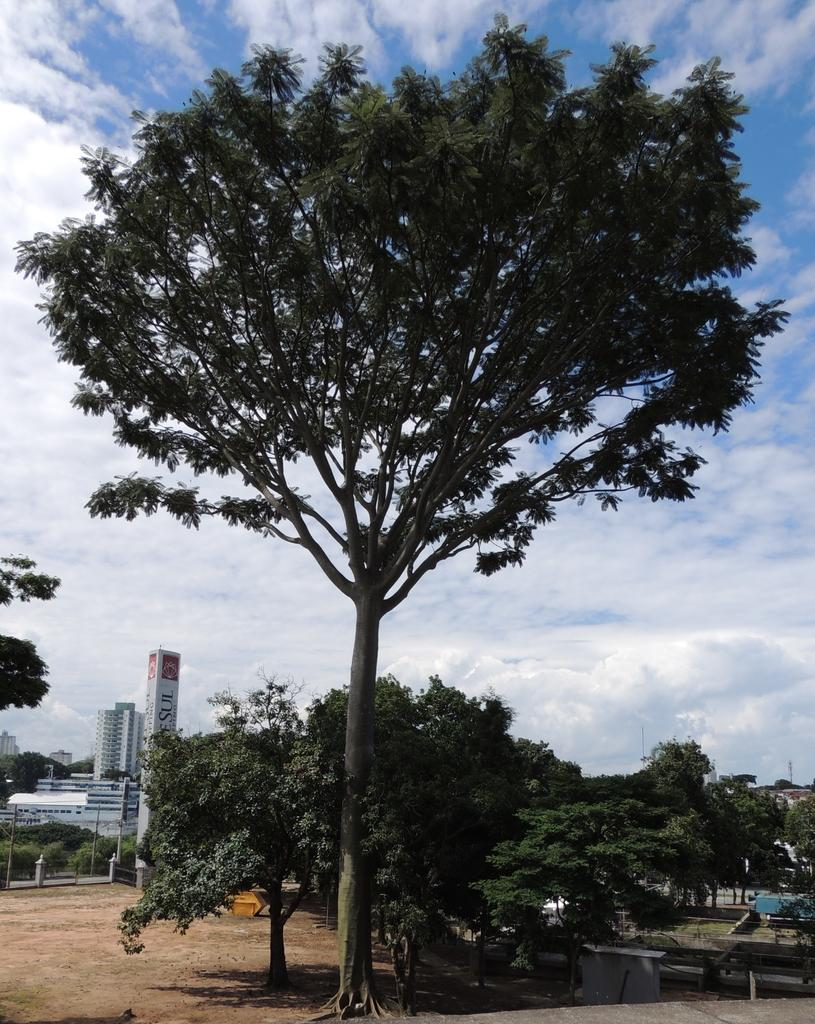What is located in the center of the image? There are trees in the center of the image. What can be seen in the background of the image? There are buildings in the background of the image. What type of ground is visible in the image? Soil is present in the image. What is visible in the sky in the image? The sky is visible in the image, and it is full of clouds. Can you tell me how many family members are having breakfast in the image? There is no family or breakfast present in the image; it features trees, buildings, soil, and a cloudy sky. 